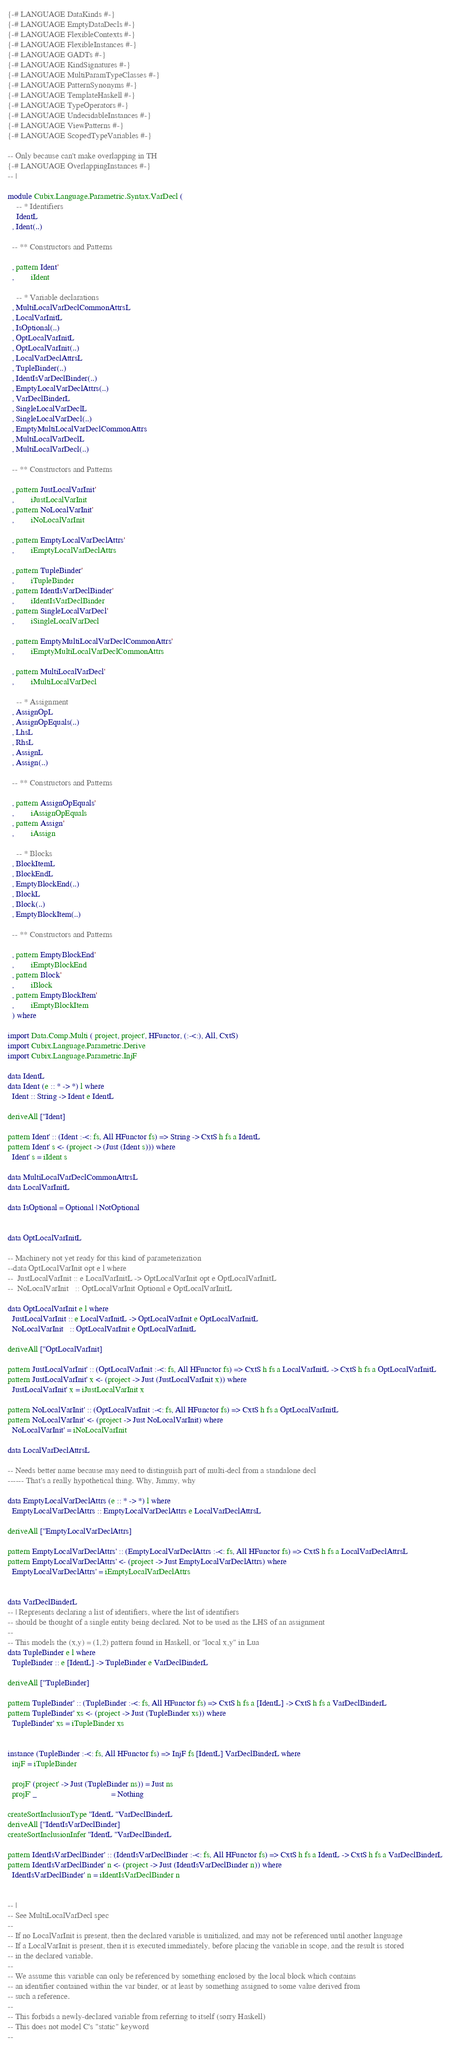Convert code to text. <code><loc_0><loc_0><loc_500><loc_500><_Haskell_>{-# LANGUAGE DataKinds #-}
{-# LANGUAGE EmptyDataDecls #-}
{-# LANGUAGE FlexibleContexts #-}
{-# LANGUAGE FlexibleInstances #-}
{-# LANGUAGE GADTs #-}
{-# LANGUAGE KindSignatures #-}
{-# LANGUAGE MultiParamTypeClasses #-}
{-# LANGUAGE PatternSynonyms #-}
{-# LANGUAGE TemplateHaskell #-}
{-# LANGUAGE TypeOperators #-}
{-# LANGUAGE UndecidableInstances #-}
{-# LANGUAGE ViewPatterns #-}
{-# LANGUAGE ScopedTypeVariables #-}

-- Only because can't make overlapping in TH
{-# LANGUAGE OverlappingInstances #-}
-- |

module Cubix.Language.Parametric.Syntax.VarDecl (
    -- * Identifiers
    IdentL
  , Ident(..)

  -- ** Constructors and Patterns

  , pattern Ident'
  ,        iIdent

    -- * Variable declarations
  , MultiLocalVarDeclCommonAttrsL
  , LocalVarInitL
  , IsOptional(..)
  , OptLocalVarInitL
  , OptLocalVarInit(..)
  , LocalVarDeclAttrsL
  , TupleBinder(..)
  , IdentIsVarDeclBinder(..)
  , EmptyLocalVarDeclAttrs(..)
  , VarDeclBinderL
  , SingleLocalVarDeclL
  , SingleLocalVarDecl(..)
  , EmptyMultiLocalVarDeclCommonAttrs
  , MultiLocalVarDeclL
  , MultiLocalVarDecl(..)

  -- ** Constructors and Patterns

  , pattern JustLocalVarInit'
  ,        iJustLocalVarInit
  , pattern NoLocalVarInit'
  ,        iNoLocalVarInit

  , pattern EmptyLocalVarDeclAttrs'
  ,        iEmptyLocalVarDeclAttrs

  , pattern TupleBinder'
  ,        iTupleBinder
  , pattern IdentIsVarDeclBinder'
  ,        iIdentIsVarDeclBinder
  , pattern SingleLocalVarDecl'
  ,        iSingleLocalVarDecl

  , pattern EmptyMultiLocalVarDeclCommonAttrs'
  ,        iEmptyMultiLocalVarDeclCommonAttrs

  , pattern MultiLocalVarDecl'
  ,        iMultiLocalVarDecl

    -- * Assignment
  , AssignOpL
  , AssignOpEquals(..)
  , LhsL
  , RhsL
  , AssignL
  , Assign(..)

  -- ** Constructors and Patterns

  , pattern AssignOpEquals'
  ,        iAssignOpEquals
  , pattern Assign'
  ,        iAssign

    -- * Blocks
  , BlockItemL
  , BlockEndL
  , EmptyBlockEnd(..)
  , BlockL
  , Block(..)
  , EmptyBlockItem(..)

  -- ** Constructors and Patterns

  , pattern EmptyBlockEnd'
  ,        iEmptyBlockEnd
  , pattern Block'
  ,        iBlock
  , pattern EmptyBlockItem'
  ,        iEmptyBlockItem
  ) where

import Data.Comp.Multi ( project, project', HFunctor, (:-<:), All, CxtS)
import Cubix.Language.Parametric.Derive
import Cubix.Language.Parametric.InjF

data IdentL
data Ident (e :: * -> *) l where
  Ident :: String -> Ident e IdentL

deriveAll [''Ident]

pattern Ident' :: (Ident :-<: fs, All HFunctor fs) => String -> CxtS h fs a IdentL
pattern Ident' s <- (project -> (Just (Ident s))) where
  Ident' s = iIdent s

data MultiLocalVarDeclCommonAttrsL
data LocalVarInitL

data IsOptional = Optional | NotOptional


data OptLocalVarInitL

-- Machinery not yet ready for this kind of parameterization
--data OptLocalVarInit opt e l where
--  JustLocalVarInit :: e LocalVarInitL -> OptLocalVarInit opt e OptLocalVarInitL
--  NoLocalVarInit   :: OptLocalVarInit Optional e OptLocalVarInitL

data OptLocalVarInit e l where
  JustLocalVarInit :: e LocalVarInitL -> OptLocalVarInit e OptLocalVarInitL
  NoLocalVarInit   :: OptLocalVarInit e OptLocalVarInitL

deriveAll [''OptLocalVarInit]

pattern JustLocalVarInit' :: (OptLocalVarInit :-<: fs, All HFunctor fs) => CxtS h fs a LocalVarInitL -> CxtS h fs a OptLocalVarInitL
pattern JustLocalVarInit' x <- (project -> Just (JustLocalVarInit x)) where
  JustLocalVarInit' x = iJustLocalVarInit x

pattern NoLocalVarInit' :: (OptLocalVarInit :-<: fs, All HFunctor fs) => CxtS h fs a OptLocalVarInitL
pattern NoLocalVarInit' <- (project -> Just NoLocalVarInit) where
  NoLocalVarInit' = iNoLocalVarInit

data LocalVarDeclAttrsL

-- Needs better name because may need to distinguish part of multi-decl from a standalone decl
------ That's a really hypothetical thing. Why, Jimmy, why

data EmptyLocalVarDeclAttrs (e :: * -> *) l where
  EmptyLocalVarDeclAttrs :: EmptyLocalVarDeclAttrs e LocalVarDeclAttrsL

deriveAll [''EmptyLocalVarDeclAttrs]

pattern EmptyLocalVarDeclAttrs' :: (EmptyLocalVarDeclAttrs :-<: fs, All HFunctor fs) => CxtS h fs a LocalVarDeclAttrsL
pattern EmptyLocalVarDeclAttrs' <- (project -> Just EmptyLocalVarDeclAttrs) where
  EmptyLocalVarDeclAttrs' = iEmptyLocalVarDeclAttrs


data VarDeclBinderL
-- | Represents declaring a list of identifiers, where the list of identifiers
-- should be thought of a single entity being declared. Not to be used as the LHS of an assignment
--
-- This models the (x,y) = (1,2) pattern found in Haskell, or "local x,y" in Lua
data TupleBinder e l where
  TupleBinder :: e [IdentL] -> TupleBinder e VarDeclBinderL

deriveAll [''TupleBinder]

pattern TupleBinder' :: (TupleBinder :-<: fs, All HFunctor fs) => CxtS h fs a [IdentL] -> CxtS h fs a VarDeclBinderL
pattern TupleBinder' xs <- (project -> Just (TupleBinder xs)) where
  TupleBinder' xs = iTupleBinder xs


instance (TupleBinder :-<: fs, All HFunctor fs) => InjF fs [IdentL] VarDeclBinderL where
  injF = iTupleBinder

  projF' (project' -> Just (TupleBinder ns)) = Just ns
  projF' _                                   = Nothing

createSortInclusionType ''IdentL ''VarDeclBinderL
deriveAll [''IdentIsVarDeclBinder]
createSortInclusionInfer ''IdentL ''VarDeclBinderL

pattern IdentIsVarDeclBinder' :: (IdentIsVarDeclBinder :-<: fs, All HFunctor fs) => CxtS h fs a IdentL -> CxtS h fs a VarDeclBinderL
pattern IdentIsVarDeclBinder' n <- (project -> Just (IdentIsVarDeclBinder n)) where
  IdentIsVarDeclBinder' n = iIdentIsVarDeclBinder n


-- |
-- See MultiLocalVarDecl spec
--
-- If no LocalVarInit is present, then the declared variable is unitialized, and may not be referenced until another language
-- If a LocalVarInit is present, then it is executed immediately, before placing the variable in scope, and the result is stored
-- in the declared variable.
--
-- We assume this variable can only be referenced by something enclosed by the local block which contains
-- an identifier contained within the var binder, or at least by something assigned to some value derived from
-- such a reference.
--
-- This forbids a newly-declared variable from referring to itself (sorry Haskell)
-- This does not model C's "static" keyword
--</code> 